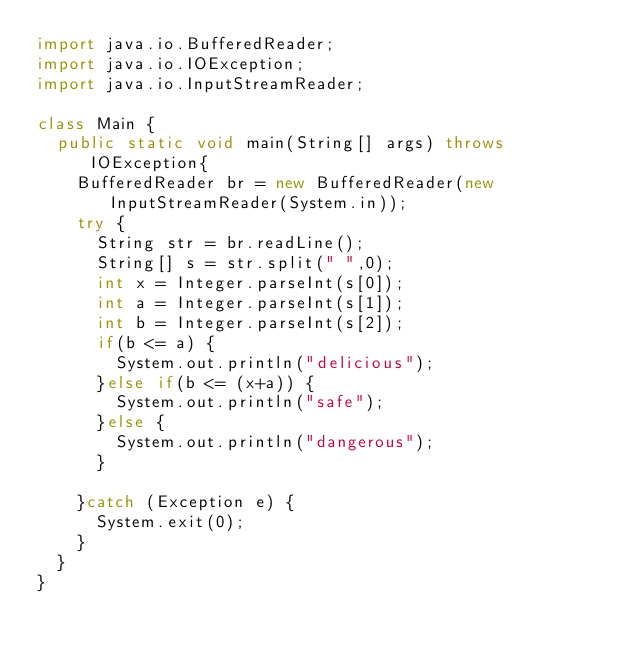Convert code to text. <code><loc_0><loc_0><loc_500><loc_500><_Java_>import java.io.BufferedReader;
import java.io.IOException;
import java.io.InputStreamReader;

class Main {
	public static void main(String[] args) throws IOException{
		BufferedReader br = new BufferedReader(new InputStreamReader(System.in));
		try {
			String str = br.readLine();
			String[] s = str.split(" ",0);
			int x = Integer.parseInt(s[0]);
			int a = Integer.parseInt(s[1]);
			int b = Integer.parseInt(s[2]);
			if(b <= a) {
				System.out.println("delicious");
			}else if(b <= (x+a)) {
				System.out.println("safe");
			}else {
				System.out.println("dangerous");
			}

		}catch (Exception e) {
			System.exit(0);
		}
	}
}
</code> 